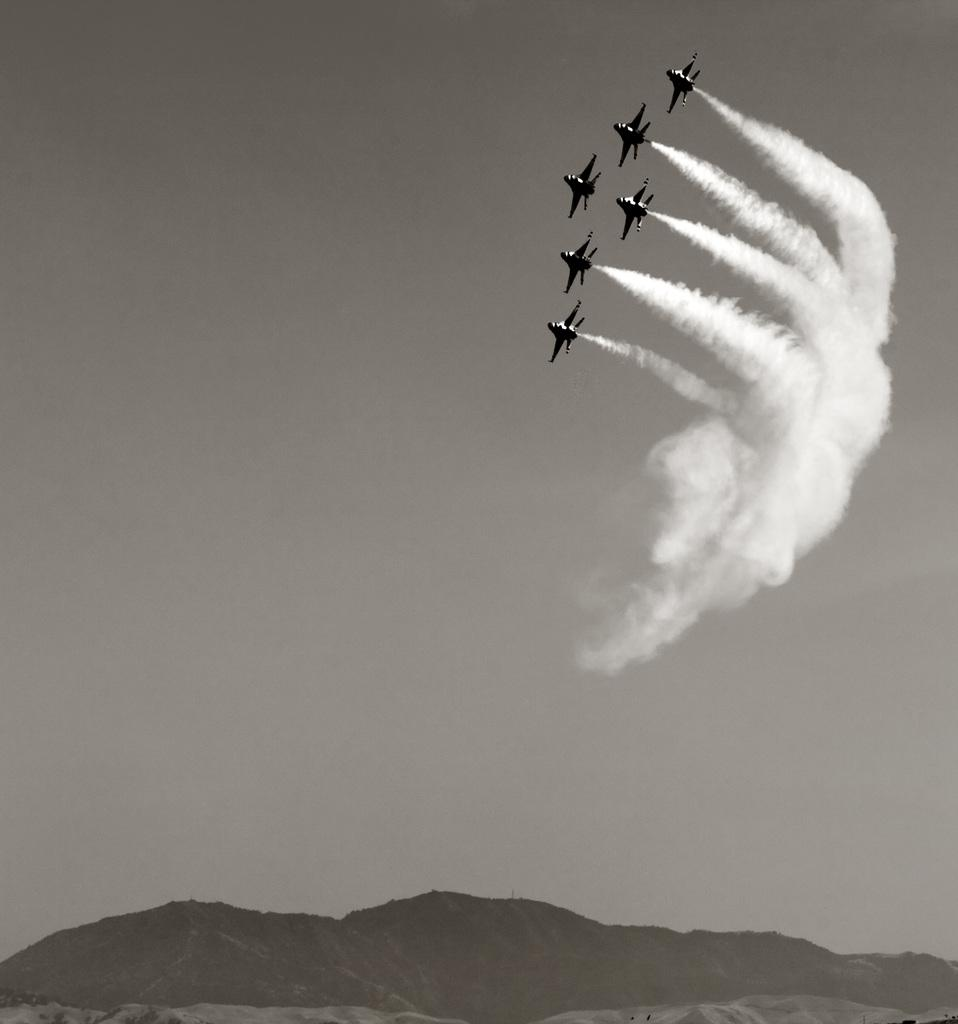What is happening in the sky in the image? There are planes in the air in the image. What can be seen in the sky as a result of the planes? There is smoke visible in the image. What type of landscape is at the bottom of the image? There are hills at the bottom of the image. What type of metal is used to construct the board in the image? There is no board present in the image; it features planes in the air and smoke in the sky. What is the purpose of the planes in the image? The purpose of the planes in the image cannot be determined from the image alone, as it does not provide context for their presence or activity. 